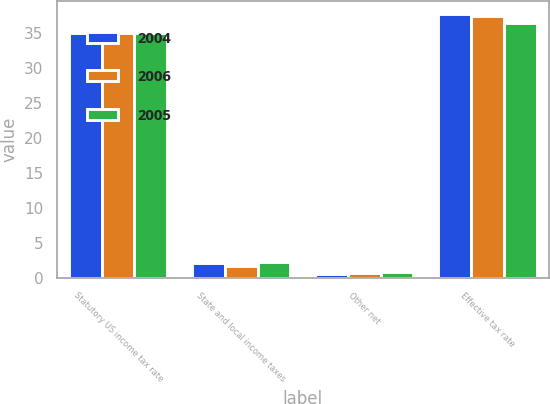Convert chart. <chart><loc_0><loc_0><loc_500><loc_500><stacked_bar_chart><ecel><fcel>Statutory US income tax rate<fcel>State and local income taxes<fcel>Other net<fcel>Effective tax rate<nl><fcel>2004<fcel>35<fcel>2.1<fcel>0.6<fcel>37.7<nl><fcel>2006<fcel>35<fcel>1.7<fcel>0.7<fcel>37.4<nl><fcel>2005<fcel>35<fcel>2.3<fcel>0.8<fcel>36.5<nl></chart> 